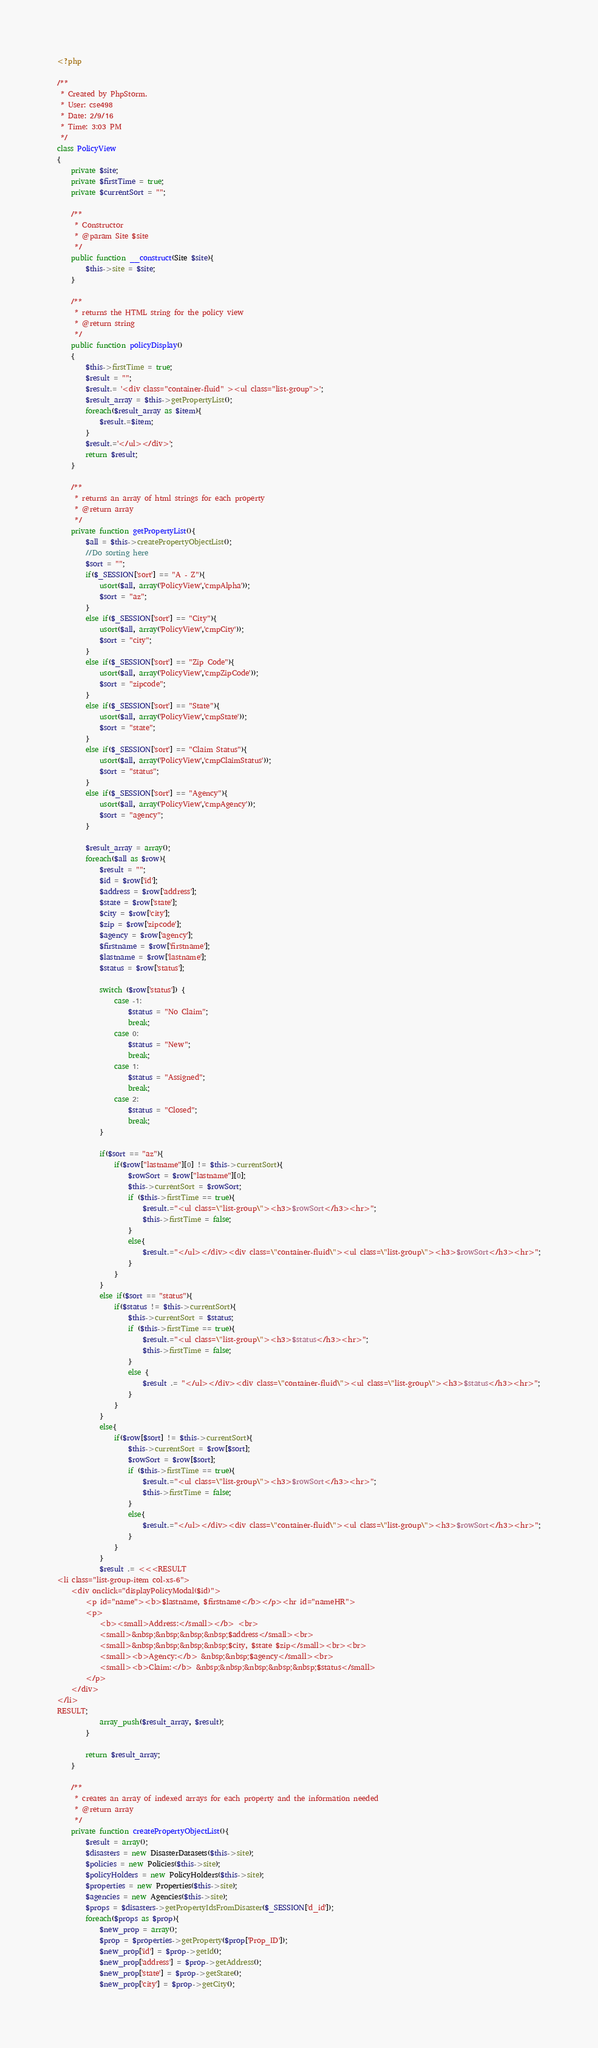Convert code to text. <code><loc_0><loc_0><loc_500><loc_500><_PHP_><?php

/**
 * Created by PhpStorm.
 * User: cse498
 * Date: 2/9/16
 * Time: 3:03 PM
 */
class PolicyView
{
    private $site;
    private $firstTime = true;
    private $currentSort = "";

    /**
     * Constructor
     * @param Site $site
     */
    public function __construct(Site $site){
        $this->site = $site;
    }

    /**
     * returns the HTML string for the policy view
     * @return string
     */
    public function policyDisplay()
    {
        $this->firstTime = true;
        $result = "";
        $result.= '<div class="container-fluid" ><ul class="list-group">';
        $result_array = $this->getPropertyList();
        foreach($result_array as $item){
            $result.=$item;
        }
        $result.='</ul></div>';
        return $result;
    }

    /**
     * returns an array of html strings for each property
     * @return array
     */
    private function getPropertyList(){
        $all = $this->createPropertyObjectList();
        //Do sorting here
        $sort = "";
        if($_SESSION['sort'] == "A - Z"){
            usort($all, array('PolicyView','cmpAlpha'));
            $sort = "az";
        }
        else if($_SESSION['sort'] == "City"){
            usort($all, array('PolicyView','cmpCity'));
            $sort = "city";
        }
        else if($_SESSION['sort'] == "Zip Code"){
            usort($all, array('PolicyView','cmpZipCode'));
            $sort = "zipcode";
        }
        else if($_SESSION['sort'] == "State"){
            usort($all, array('PolicyView','cmpState'));
            $sort = "state";
        }
        else if($_SESSION['sort'] == "Claim Status"){
            usort($all, array('PolicyView','cmpClaimStatus'));
            $sort = "status";
        }
        else if($_SESSION['sort'] == "Agency"){
            usort($all, array('PolicyView','cmpAgency'));
            $sort = "agency";
        }

        $result_array = array();
        foreach($all as $row){
            $result = "";
            $id = $row['id'];
            $address = $row['address'];
            $state = $row['state'];
            $city = $row['city'];
            $zip = $row['zipcode'];
            $agency = $row['agency'];
            $firstname = $row['firstname'];
            $lastname = $row['lastname'];
            $status = $row['status'];

            switch ($row['status']) {
                case -1:
                    $status = "No Claim";
                    break;
                case 0:
                    $status = "New";
                    break;
                case 1:
                    $status = "Assigned";
                    break;
                case 2:
                    $status = "Closed";
                    break;
            }

            if($sort == "az"){
                if($row["lastname"][0] != $this->currentSort){
                    $rowSort = $row["lastname"][0];
                    $this->currentSort = $rowSort;
                    if ($this->firstTime == true){
                        $result.="<ul class=\"list-group\"><h3>$rowSort</h3><hr>";
                        $this->firstTime = false;
                    }
                    else{
                        $result.="</ul></div><div class=\"container-fluid\"><ul class=\"list-group\"><h3>$rowSort</h3><hr>";
                    }
                }
            }
            else if($sort == "status"){
                if($status != $this->currentSort){
                    $this->currentSort = $status;
                    if ($this->firstTime == true){
                        $result.="<ul class=\"list-group\"><h3>$status</h3><hr>";
                        $this->firstTime = false;
                    }
                    else {
                        $result .= "</ul></div><div class=\"container-fluid\"><ul class=\"list-group\"><h3>$status</h3><hr>";
                    }
                }
            }
            else{
                if($row[$sort] != $this->currentSort){
                    $this->currentSort = $row[$sort];
                    $rowSort = $row[$sort];
                    if ($this->firstTime == true){
                        $result.="<ul class=\"list-group\"><h3>$rowSort</h3><hr>";
                        $this->firstTime = false;
                    }
                    else{
                        $result.="</ul></div><div class=\"container-fluid\"><ul class=\"list-group\"><h3>$rowSort</h3><hr>";
                    }
                }
            }
            $result .= <<<RESULT
<li class="list-group-item col-xs-6">
    <div onclick="displayPolicyModal($id)">
        <p id="name"><b>$lastname, $firstname</b></p><hr id="nameHR">
        <p>
            <b><small>Address:</small></b> <br>
            <small>&nbsp;&nbsp;&nbsp;&nbsp;$address</small><br>
            <small>&nbsp;&nbsp;&nbsp;&nbsp;$city, $state $zip</small><br><br>
            <small><b>Agency:</b> &nbsp;&nbsp;$agency</small><br>
            <small><b>Claim:</b> &nbsp;&nbsp;&nbsp;&nbsp;&nbsp;$status</small>
        </p>
    </div>
</li>
RESULT;
            array_push($result_array, $result);
        }

        return $result_array;
    }

    /**
     * creates an array of indexed arrays for each property and the information needed
     * @return array
     */
    private function createPropertyObjectList(){
        $result = array();
        $disasters = new DisasterDatasets($this->site);
        $policies = new Policies($this->site);
        $policyHolders = new PolicyHolders($this->site);
        $properties = new Properties($this->site);
        $agencies = new Agencies($this->site);
        $props = $disasters->getPropertyIdsFromDisaster($_SESSION['d_id']);
        foreach($props as $prop){
            $new_prop = array();
            $prop = $properties->getProperty($prop['Prop_ID']);
            $new_prop['id'] = $prop->getId();
            $new_prop['address'] = $prop->getAddress();
            $new_prop['state'] = $prop->getState();
            $new_prop['city'] = $prop->getCity();</code> 